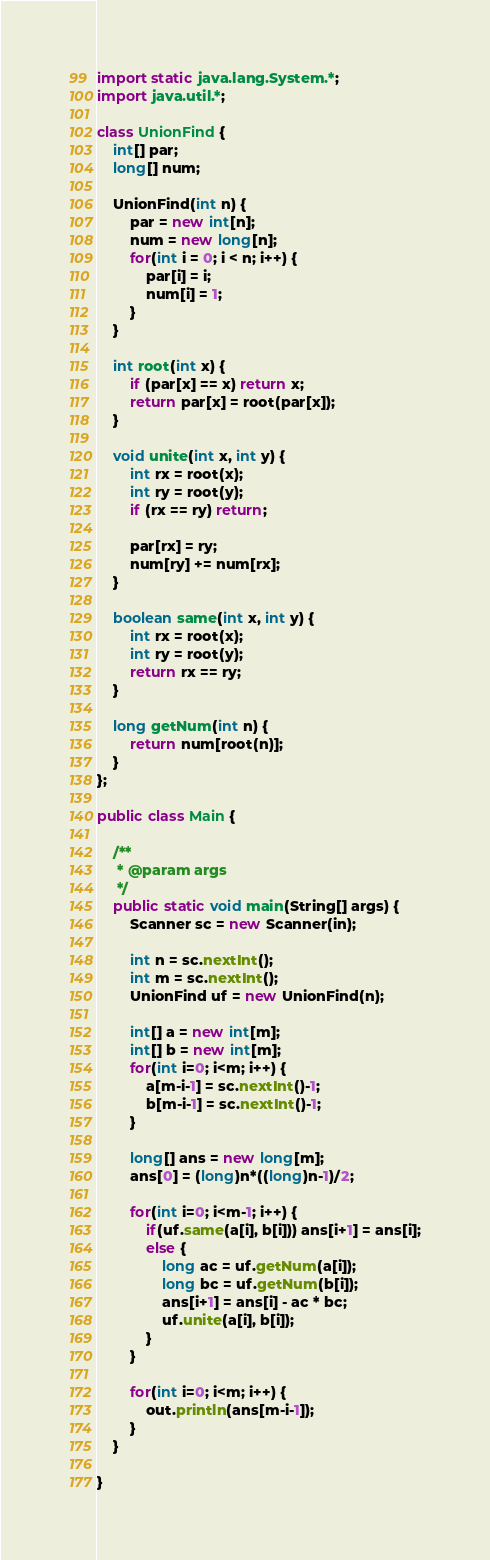<code> <loc_0><loc_0><loc_500><loc_500><_Java_>
import static java.lang.System.*;
import java.util.*;

class UnionFind {
    int[] par;
    long[] num;

    UnionFind(int n) { 
    	par = new int[n];
    	num = new long[n];
        for(int i = 0; i < n; i++) {
        	par[i] = i;
        	num[i] = 1;
        }
    }

    int root(int x) {
        if (par[x] == x) return x;
        return par[x] = root(par[x]);
    }

    void unite(int x, int y) {
        int rx = root(x); 
        int ry = root(y);
        if (rx == ry) return; 
        
        par[rx] = ry;
        num[ry] += num[rx];
    }

    boolean same(int x, int y) {
        int rx = root(x);
        int ry = root(y);
        return rx == ry;
    }
    
    long getNum(int n) {
    	return num[root(n)];
    }
};

public class Main {

	/**
	 * @param args
	 */
	public static void main(String[] args) {
		Scanner sc = new Scanner(in);
		
		int n = sc.nextInt();
		int m = sc.nextInt();
		UnionFind uf = new UnionFind(n);

		int[] a = new int[m];
		int[] b = new int[m];
		for(int i=0; i<m; i++) {
			a[m-i-1] = sc.nextInt()-1;
			b[m-i-1] = sc.nextInt()-1;
		}
		
		long[] ans = new long[m];
		ans[0] = (long)n*((long)n-1)/2;
		
		for(int i=0; i<m-1; i++) {
			if(uf.same(a[i], b[i])) ans[i+1] = ans[i];
			else {
				long ac = uf.getNum(a[i]);
				long bc = uf.getNum(b[i]);
				ans[i+1] = ans[i] - ac * bc;
				uf.unite(a[i], b[i]);
			}
		}

		for(int i=0; i<m; i++) {
			out.println(ans[m-i-1]); 
		}
	}

}
</code> 